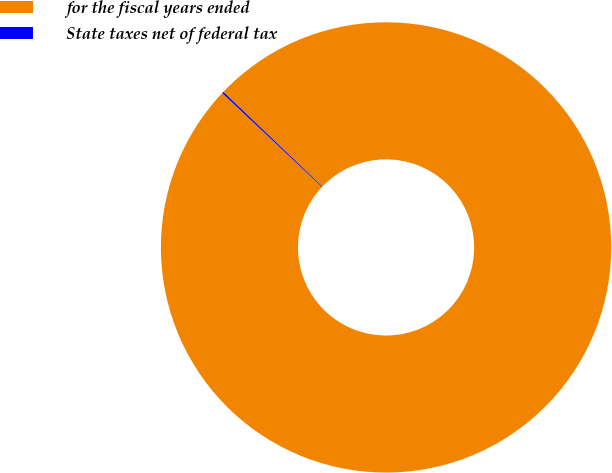<chart> <loc_0><loc_0><loc_500><loc_500><pie_chart><fcel>for the fiscal years ended<fcel>State taxes net of federal tax<nl><fcel>99.88%<fcel>0.12%<nl></chart> 